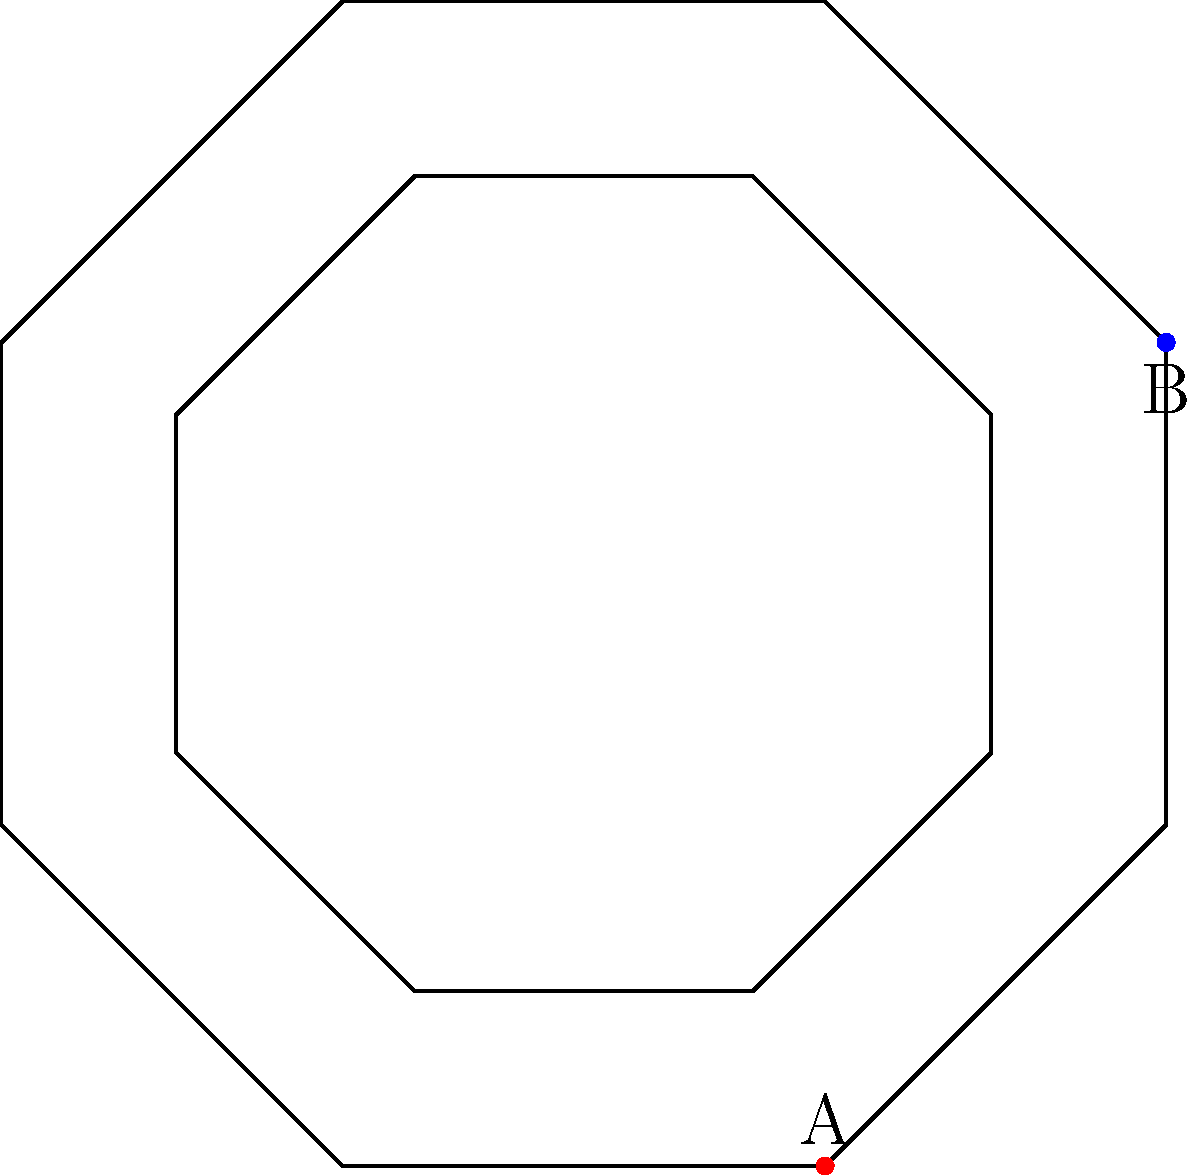In an ancient Roman villa, you've discovered an octagonal mosaic pattern with nested octagons. The outer octagon has a diameter (distance between opposite vertices) of 3 meters. What is the area of the shaded region between the outer octagon and the next inner octagon if the inner octagon is scaled down by a factor of 0.7? Let's approach this step-by-step:

1) First, we need to calculate the area of the outer octagon:
   - Area of a regular octagon = $2a^2(1+\sqrt{2})$, where $a$ is the side length
   - Diameter = $2a\sqrt{2+\sqrt{2}}$
   - Given diameter = 3m, so $3 = 2a\sqrt{2+\sqrt{2}}$
   - Solving for $a$: $a = \frac{3}{2\sqrt{2+\sqrt{2}}} \approx 0.9239$m

2) Now we can calculate the area of the outer octagon:
   $A_{outer} = 2(0.9239)^2(1+\sqrt{2}) \approx 6.2132$m²

3) The inner octagon is scaled down by a factor of 0.7:
   - Its side length will be $0.7 * 0.9239 = 0.6467$m
   - Area of inner octagon: $A_{inner} = 2(0.6467)^2(1+\sqrt{2}) \approx 3.0445$m²

4) The shaded area is the difference between these two areas:
   $A_{shaded} = A_{outer} - A_{inner} = 6.2132 - 3.0445 = 3.1687$m²

Therefore, the shaded area is approximately 3.1687 square meters.
Answer: $3.1687$m² 